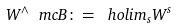Convert formula to latex. <formula><loc_0><loc_0><loc_500><loc_500>W ^ { \wedge } \ m c { B } \colon = \ h o l i m _ { s } W ^ { s }</formula> 